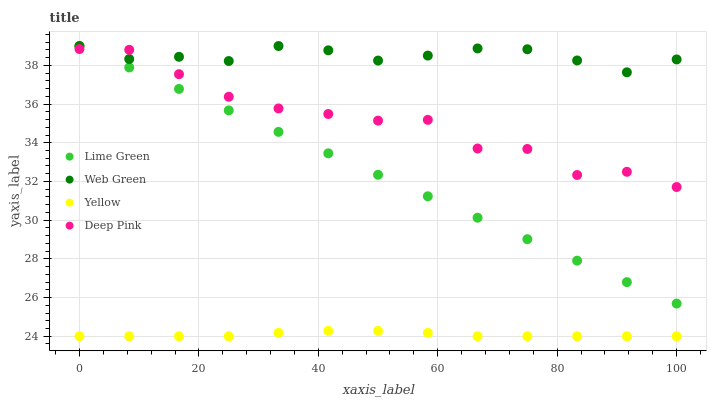Does Yellow have the minimum area under the curve?
Answer yes or no. Yes. Does Web Green have the maximum area under the curve?
Answer yes or no. Yes. Does Lime Green have the minimum area under the curve?
Answer yes or no. No. Does Lime Green have the maximum area under the curve?
Answer yes or no. No. Is Lime Green the smoothest?
Answer yes or no. Yes. Is Deep Pink the roughest?
Answer yes or no. Yes. Is Yellow the smoothest?
Answer yes or no. No. Is Yellow the roughest?
Answer yes or no. No. Does Yellow have the lowest value?
Answer yes or no. Yes. Does Lime Green have the lowest value?
Answer yes or no. No. Does Web Green have the highest value?
Answer yes or no. Yes. Does Yellow have the highest value?
Answer yes or no. No. Is Yellow less than Lime Green?
Answer yes or no. Yes. Is Lime Green greater than Yellow?
Answer yes or no. Yes. Does Deep Pink intersect Web Green?
Answer yes or no. Yes. Is Deep Pink less than Web Green?
Answer yes or no. No. Is Deep Pink greater than Web Green?
Answer yes or no. No. Does Yellow intersect Lime Green?
Answer yes or no. No. 